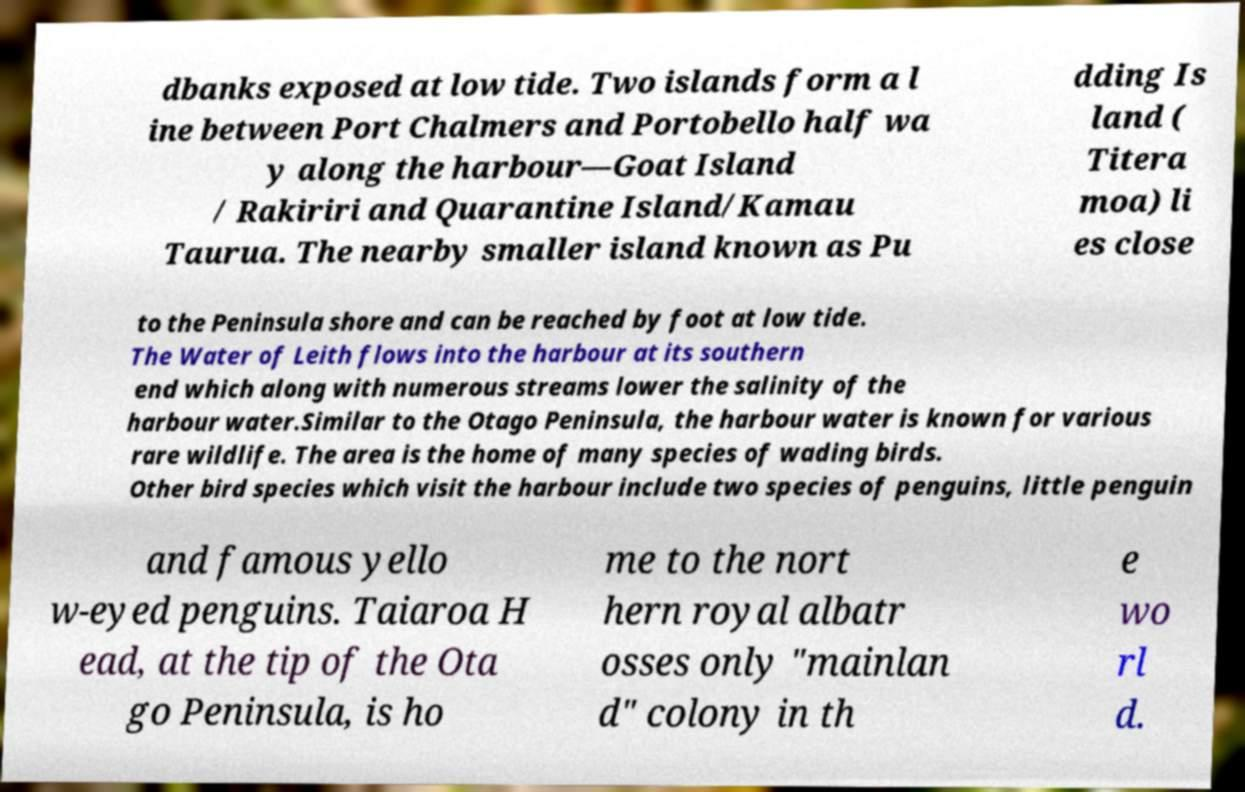I need the written content from this picture converted into text. Can you do that? dbanks exposed at low tide. Two islands form a l ine between Port Chalmers and Portobello half wa y along the harbour—Goat Island / Rakiriri and Quarantine Island/Kamau Taurua. The nearby smaller island known as Pu dding Is land ( Titera moa) li es close to the Peninsula shore and can be reached by foot at low tide. The Water of Leith flows into the harbour at its southern end which along with numerous streams lower the salinity of the harbour water.Similar to the Otago Peninsula, the harbour water is known for various rare wildlife. The area is the home of many species of wading birds. Other bird species which visit the harbour include two species of penguins, little penguin and famous yello w-eyed penguins. Taiaroa H ead, at the tip of the Ota go Peninsula, is ho me to the nort hern royal albatr osses only "mainlan d" colony in th e wo rl d. 